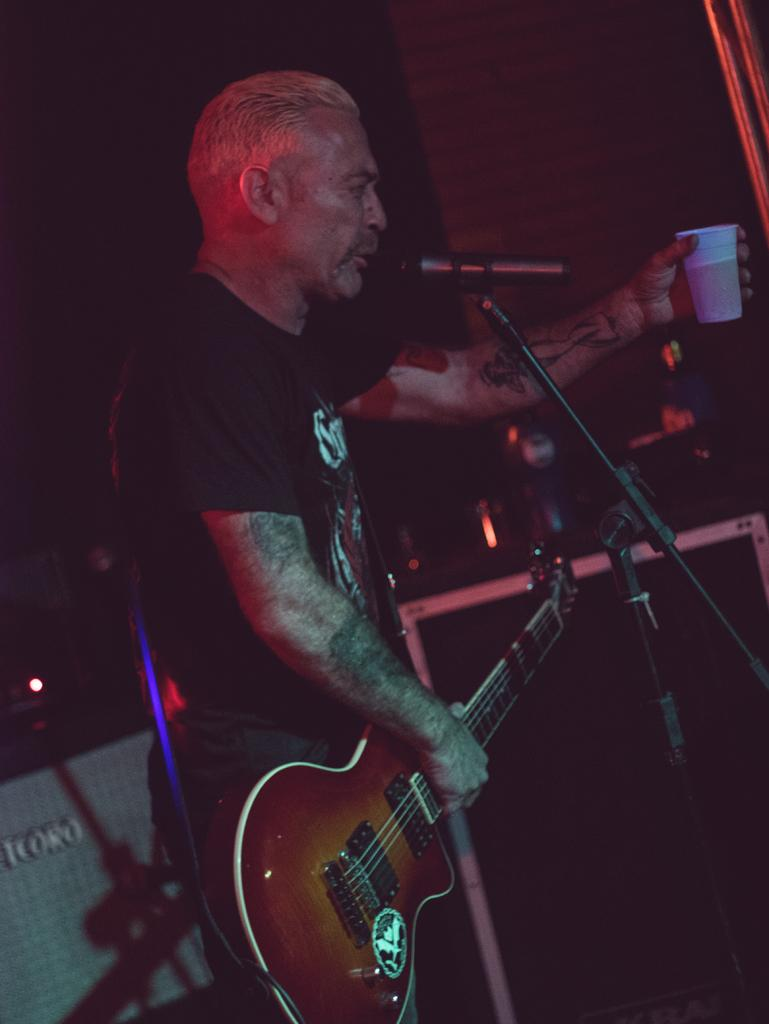What is the main subject of the image? The main subject of the image is a guy. What is the guy wearing in the image? The guy is wearing a black shirt in the image. What is the guy holding in his right hand? The guy is holding a guitar in his right hand. What is the guy holding in his left hand? The guy is holding a glass in his left hand. What is the guy standing in front of in the image? The guy is standing in front of a microphone. How many books can be seen on the guy's dress in the image? There is no dress or books present in the image. The guy is wearing a black shirt and holding a guitar and a glass. 